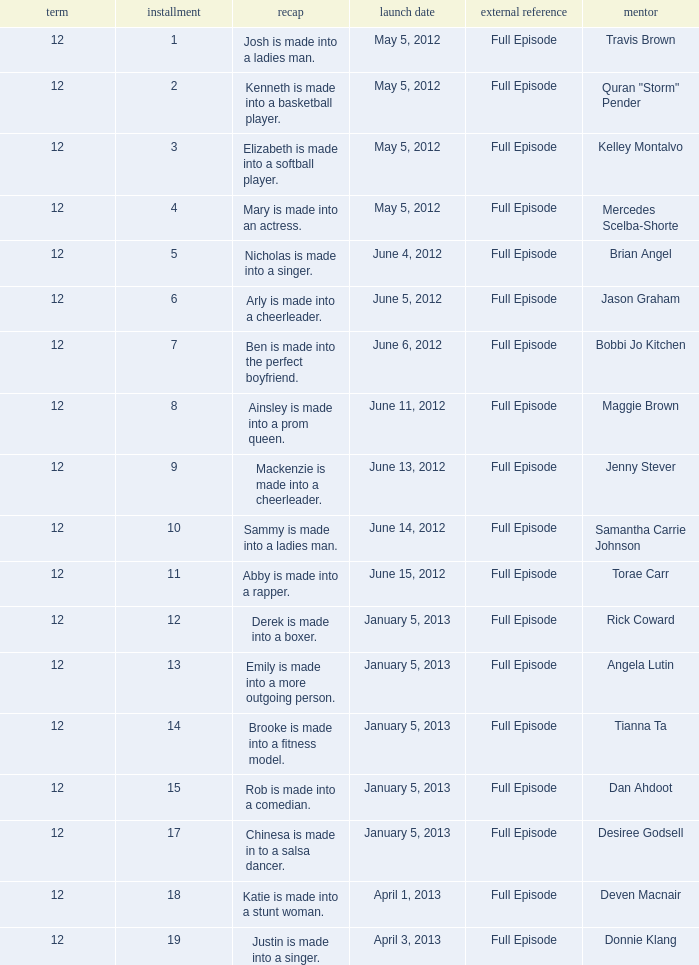Help me parse the entirety of this table. {'header': ['term', 'installment', 'recap', 'launch date', 'external reference', 'mentor'], 'rows': [['12', '1', 'Josh is made into a ladies man.', 'May 5, 2012', 'Full Episode', 'Travis Brown'], ['12', '2', 'Kenneth is made into a basketball player.', 'May 5, 2012', 'Full Episode', 'Quran "Storm" Pender'], ['12', '3', 'Elizabeth is made into a softball player.', 'May 5, 2012', 'Full Episode', 'Kelley Montalvo'], ['12', '4', 'Mary is made into an actress.', 'May 5, 2012', 'Full Episode', 'Mercedes Scelba-Shorte'], ['12', '5', 'Nicholas is made into a singer.', 'June 4, 2012', 'Full Episode', 'Brian Angel'], ['12', '6', 'Arly is made into a cheerleader.', 'June 5, 2012', 'Full Episode', 'Jason Graham'], ['12', '7', 'Ben is made into the perfect boyfriend.', 'June 6, 2012', 'Full Episode', 'Bobbi Jo Kitchen'], ['12', '8', 'Ainsley is made into a prom queen.', 'June 11, 2012', 'Full Episode', 'Maggie Brown'], ['12', '9', 'Mackenzie is made into a cheerleader.', 'June 13, 2012', 'Full Episode', 'Jenny Stever'], ['12', '10', 'Sammy is made into a ladies man.', 'June 14, 2012', 'Full Episode', 'Samantha Carrie Johnson'], ['12', '11', 'Abby is made into a rapper.', 'June 15, 2012', 'Full Episode', 'Torae Carr'], ['12', '12', 'Derek is made into a boxer.', 'January 5, 2013', 'Full Episode', 'Rick Coward'], ['12', '13', 'Emily is made into a more outgoing person.', 'January 5, 2013', 'Full Episode', 'Angela Lutin'], ['12', '14', 'Brooke is made into a fitness model.', 'January 5, 2013', 'Full Episode', 'Tianna Ta'], ['12', '15', 'Rob is made into a comedian.', 'January 5, 2013', 'Full Episode', 'Dan Ahdoot'], ['12', '17', 'Chinesa is made in to a salsa dancer.', 'January 5, 2013', 'Full Episode', 'Desiree Godsell'], ['12', '18', 'Katie is made into a stunt woman.', 'April 1, 2013', 'Full Episode', 'Deven Macnair'], ['12', '19', 'Justin is made into a singer.', 'April 3, 2013', 'Full Episode', 'Donnie Klang']]} Name the coach for  emily is made into a more outgoing person. Angela Lutin. 